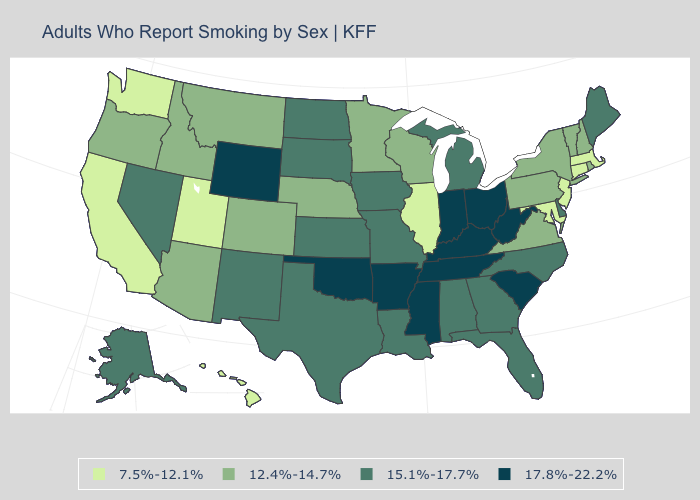What is the lowest value in the MidWest?
Concise answer only. 7.5%-12.1%. What is the value of North Carolina?
Concise answer only. 15.1%-17.7%. What is the highest value in states that border Maine?
Give a very brief answer. 12.4%-14.7%. Does Hawaii have the highest value in the West?
Quick response, please. No. Name the states that have a value in the range 15.1%-17.7%?
Answer briefly. Alabama, Alaska, Delaware, Florida, Georgia, Iowa, Kansas, Louisiana, Maine, Michigan, Missouri, Nevada, New Mexico, North Carolina, North Dakota, South Dakota, Texas. Name the states that have a value in the range 7.5%-12.1%?
Keep it brief. California, Connecticut, Hawaii, Illinois, Maryland, Massachusetts, New Jersey, Utah, Washington. What is the value of Massachusetts?
Quick response, please. 7.5%-12.1%. What is the value of Massachusetts?
Write a very short answer. 7.5%-12.1%. Which states hav the highest value in the South?
Write a very short answer. Arkansas, Kentucky, Mississippi, Oklahoma, South Carolina, Tennessee, West Virginia. Which states have the lowest value in the South?
Give a very brief answer. Maryland. Does Minnesota have the same value as New Hampshire?
Write a very short answer. Yes. Name the states that have a value in the range 7.5%-12.1%?
Short answer required. California, Connecticut, Hawaii, Illinois, Maryland, Massachusetts, New Jersey, Utah, Washington. Name the states that have a value in the range 12.4%-14.7%?
Quick response, please. Arizona, Colorado, Idaho, Minnesota, Montana, Nebraska, New Hampshire, New York, Oregon, Pennsylvania, Rhode Island, Vermont, Virginia, Wisconsin. Among the states that border Rhode Island , which have the lowest value?
Answer briefly. Connecticut, Massachusetts. What is the value of Montana?
Write a very short answer. 12.4%-14.7%. 